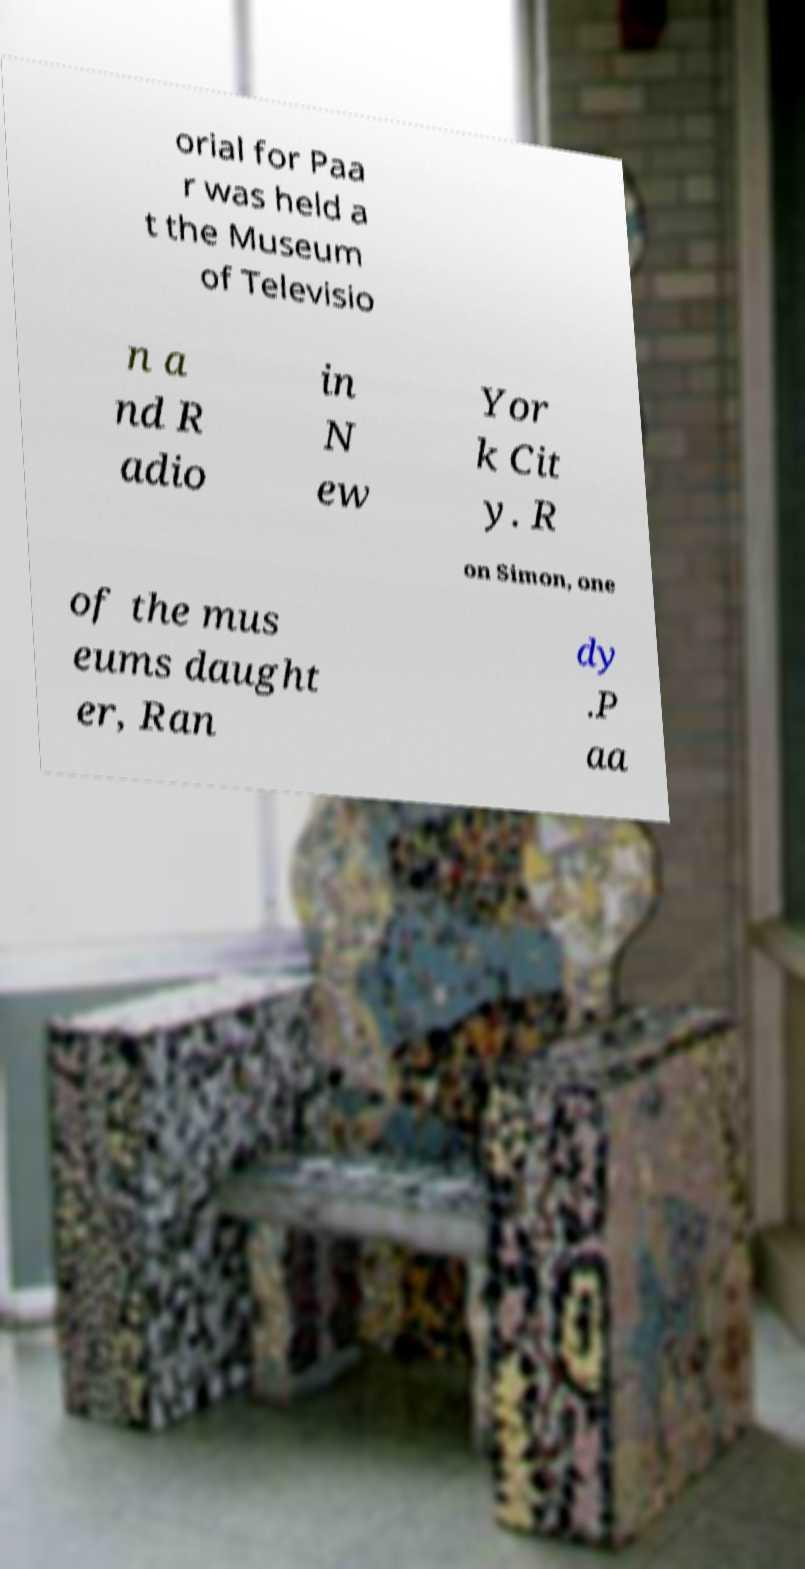There's text embedded in this image that I need extracted. Can you transcribe it verbatim? orial for Paa r was held a t the Museum of Televisio n a nd R adio in N ew Yor k Cit y. R on Simon, one of the mus eums daught er, Ran dy .P aa 